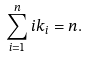Convert formula to latex. <formula><loc_0><loc_0><loc_500><loc_500>\sum _ { i = 1 } ^ { n } i k _ { i } = n .</formula> 